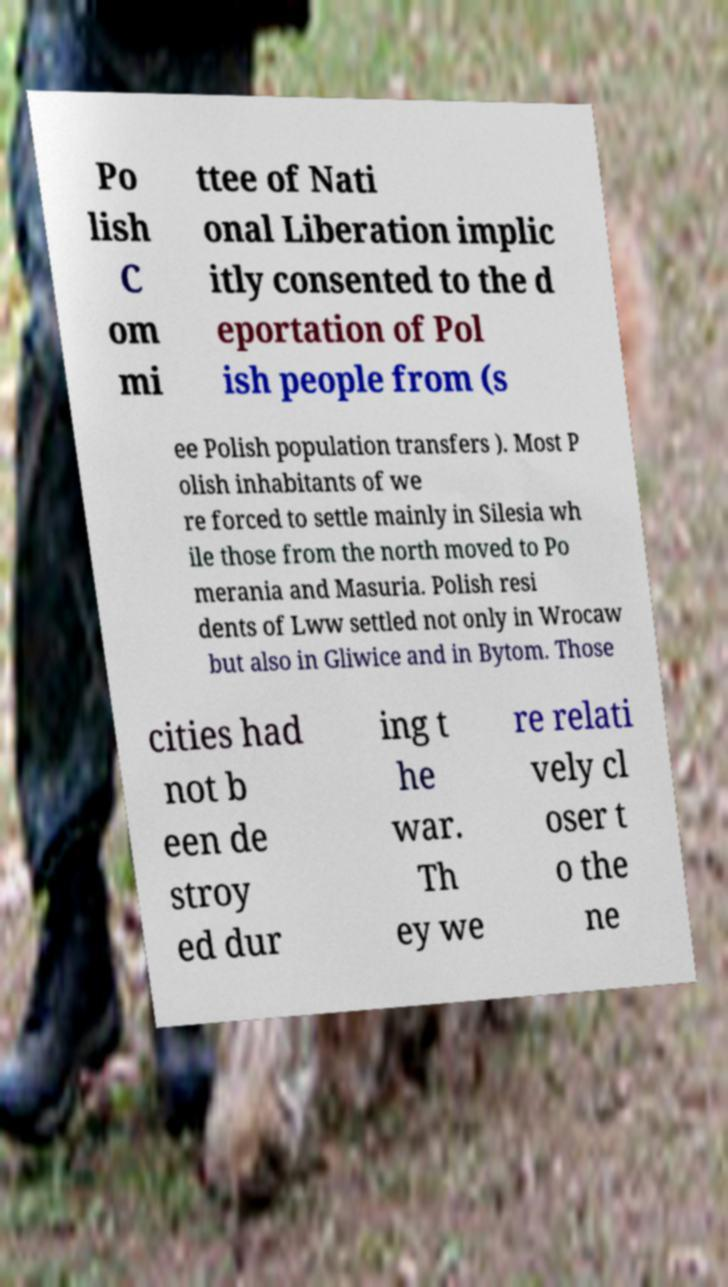Can you read and provide the text displayed in the image?This photo seems to have some interesting text. Can you extract and type it out for me? Po lish C om mi ttee of Nati onal Liberation implic itly consented to the d eportation of Pol ish people from (s ee Polish population transfers ). Most P olish inhabitants of we re forced to settle mainly in Silesia wh ile those from the north moved to Po merania and Masuria. Polish resi dents of Lww settled not only in Wrocaw but also in Gliwice and in Bytom. Those cities had not b een de stroy ed dur ing t he war. Th ey we re relati vely cl oser t o the ne 